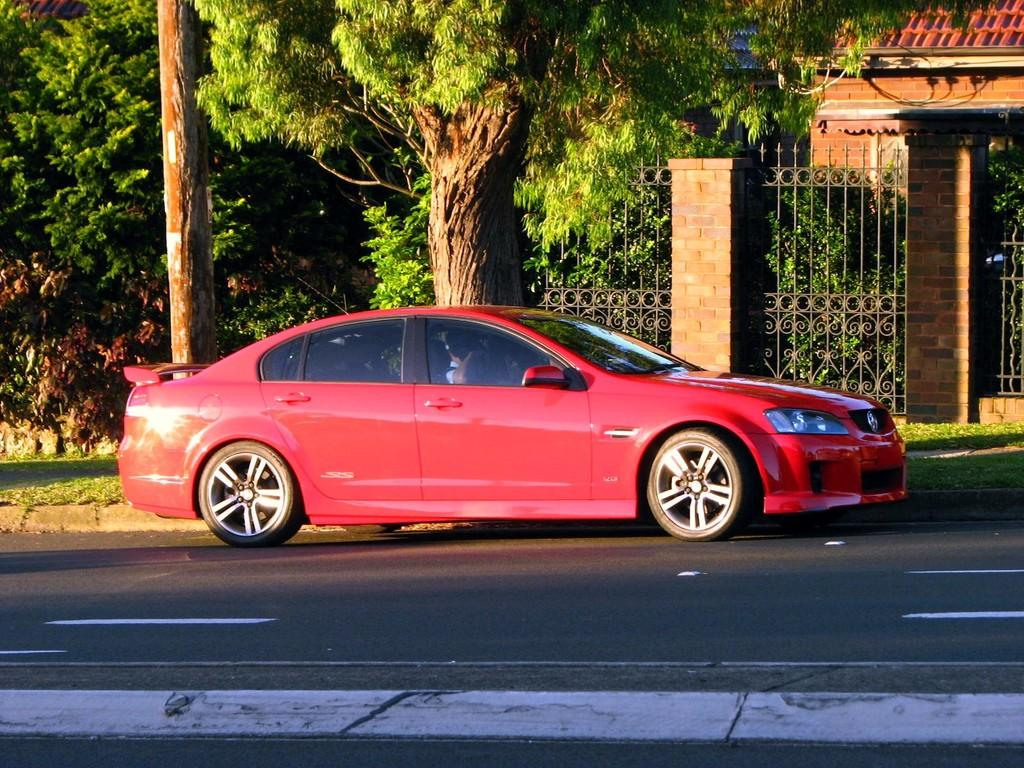What color is the car in the image? The car in the image is red. Where is the car located? The car is on a road. What can be seen behind the car? There are trees behind the car. What type of structure is present in the image? There is a building present in the image. What type of stem can be seen growing from the car in the image? A: There is no stem growing from the car in the image; it is a car, not a plant. 